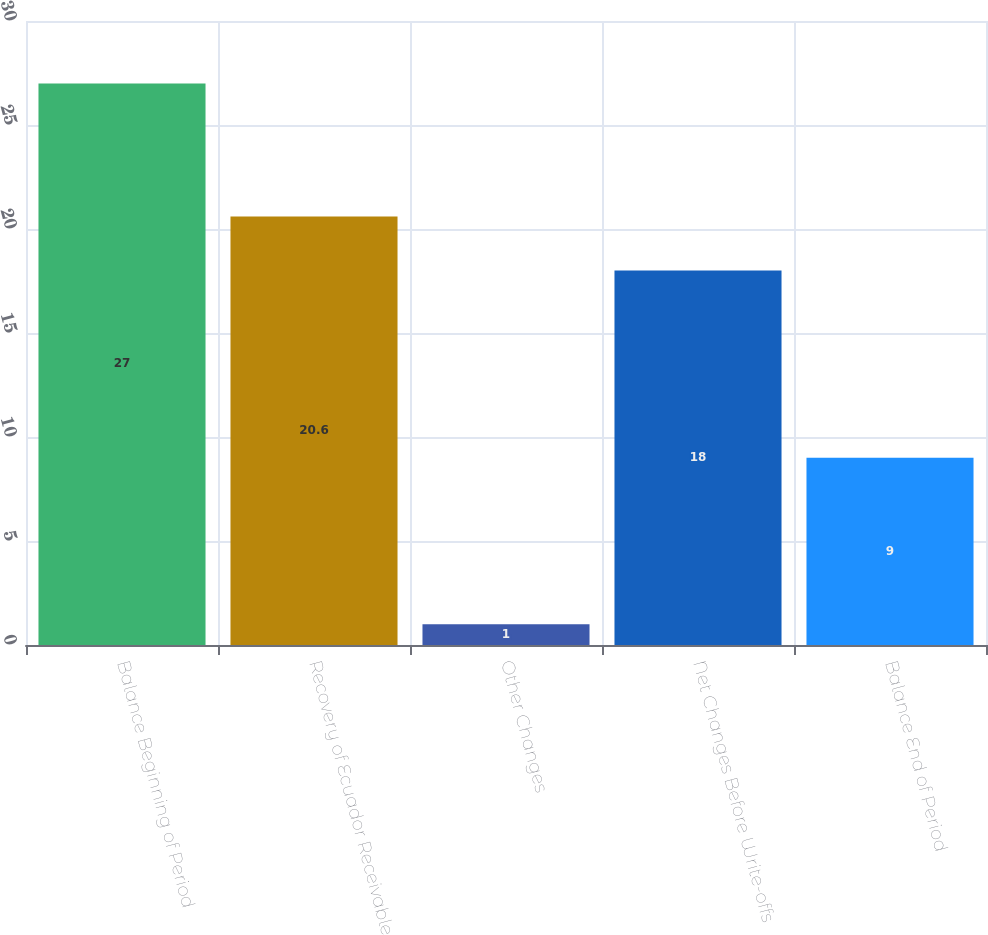Convert chart to OTSL. <chart><loc_0><loc_0><loc_500><loc_500><bar_chart><fcel>Balance Beginning of Period<fcel>Recovery of Ecuador Receivable<fcel>Other Changes<fcel>Net Changes Before Write-offs<fcel>Balance End of Period<nl><fcel>27<fcel>20.6<fcel>1<fcel>18<fcel>9<nl></chart> 